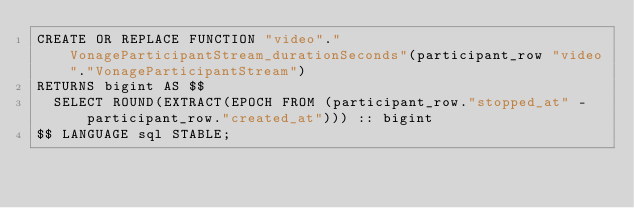<code> <loc_0><loc_0><loc_500><loc_500><_SQL_>CREATE OR REPLACE FUNCTION "video"."VonageParticipantStream_durationSeconds"(participant_row "video"."VonageParticipantStream")
RETURNS bigint AS $$
  SELECT ROUND(EXTRACT(EPOCH FROM (participant_row."stopped_at" - participant_row."created_at"))) :: bigint
$$ LANGUAGE sql STABLE;
</code> 